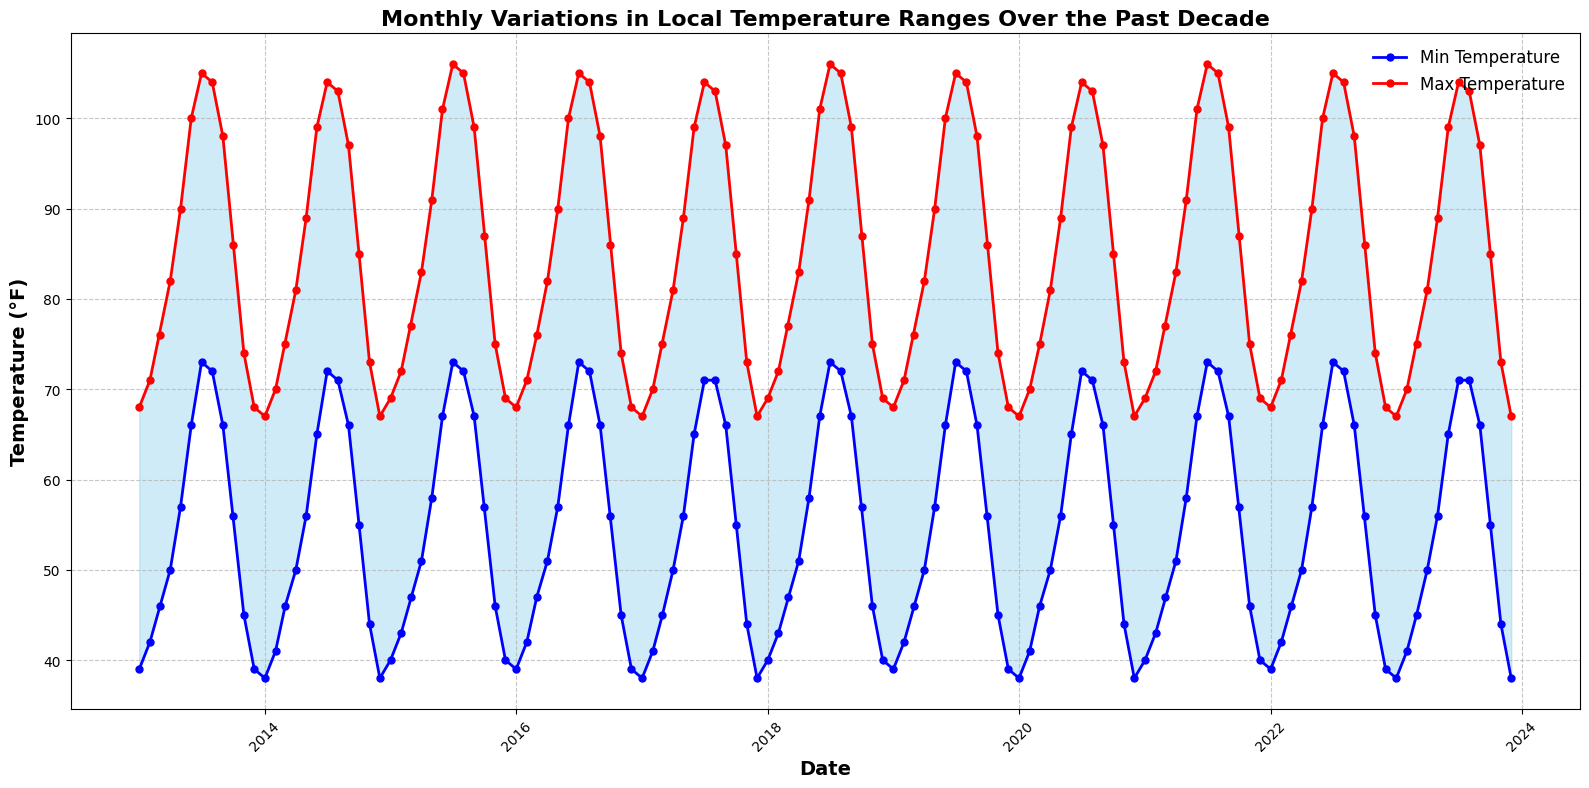What is the range of temperatures in January 2013? The range of temperatures can be found by subtracting the minimum temperature from the maximum temperature. For January 2013, the min temperature is 39°F, and the max temperature is 68°F. So, the range is 68 - 39 = 29°F
Answer: 29°F Which month had the highest maximum temperature over the past decade? By observing the area chart, the highest maximum temperature line peaks in July 2015 and July 2018 at 106°F.
Answer: July What is the average max temperature in August across the years 2013-2023? The max temperatures for August from 2013 to 2023 are: 104, 103, 105, 104, 103, 105, 104, 103, 104, 103, and 103°F. Summing these and then dividing by 11 gives (104 + 103 + 105 + 104 + 103 + 105 + 104 + 103 + 104 + 103 + 103)/11 = 103.9°F
Answer: 103.9°F Is there any month where the minimum temperature stayed the same for two consecutive years? Visualize the minimum temperature line on the plot to see if it stays flat for two consecutive points. For January, the min temperatures in 2016 and 2017 are both 39°F, for instance.
Answer: Yes, January 2016 and 2017 How does the temperature range in June 2015 compare to June 2020? Calculate the range for each June. For June 2015, it's 101 - 67 = 34°F, and for June 2020, it's 99 - 65 = 34°F. Comparing them shows they are equal.
Answer: They are equal, both 34°F Which year had the lowest minimum temperature in December? Check the minimum temperature line for December across all years. The lowest point is in December 2014 and December 2017 with a temperature of 38°F.
Answer: 2014 and 2017 What is the difference between the highest maximum temperature and the lowest minimum temperature recorded in the decade? The highest max temperature is 106°F, observed in July 2015 and July 2018. The lowest min temperature is 38°F, observed in January 2014, December 2014, January 2017, December 2017, January 2020, December 2020, January 2023, and December 2023. The difference is 106 - 38 = 68°F
Answer: 68°F 